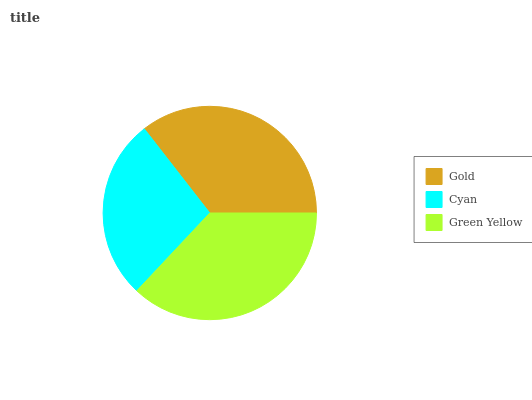Is Cyan the minimum?
Answer yes or no. Yes. Is Green Yellow the maximum?
Answer yes or no. Yes. Is Green Yellow the minimum?
Answer yes or no. No. Is Cyan the maximum?
Answer yes or no. No. Is Green Yellow greater than Cyan?
Answer yes or no. Yes. Is Cyan less than Green Yellow?
Answer yes or no. Yes. Is Cyan greater than Green Yellow?
Answer yes or no. No. Is Green Yellow less than Cyan?
Answer yes or no. No. Is Gold the high median?
Answer yes or no. Yes. Is Gold the low median?
Answer yes or no. Yes. Is Cyan the high median?
Answer yes or no. No. Is Green Yellow the low median?
Answer yes or no. No. 